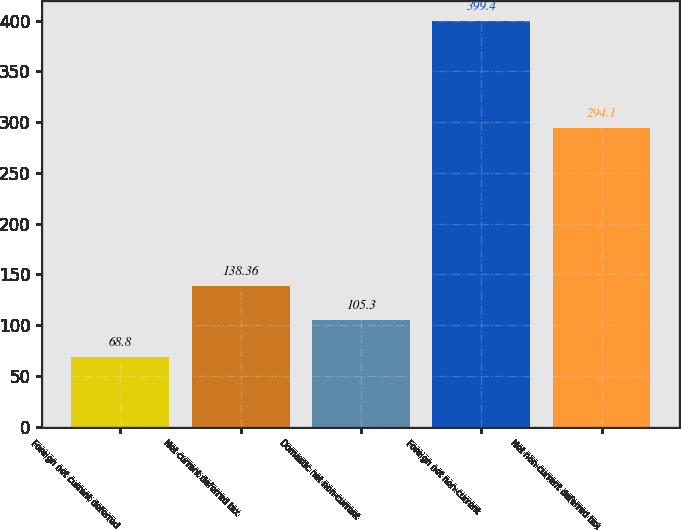Convert chart. <chart><loc_0><loc_0><loc_500><loc_500><bar_chart><fcel>Foreign net current deferred<fcel>Net current deferred tax<fcel>Domestic net non-current<fcel>Foreign net non-current<fcel>Net non-current deferred tax<nl><fcel>68.8<fcel>138.36<fcel>105.3<fcel>399.4<fcel>294.1<nl></chart> 